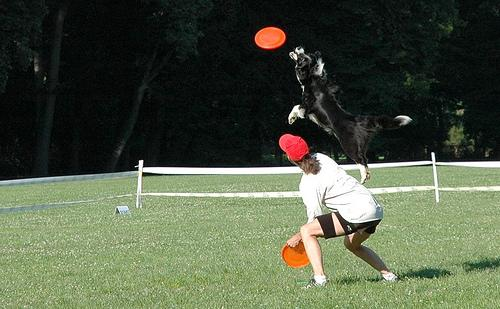What is the primary activity captured in the image? A person playing frisbee with a black and white dog in an outdoor field with lush green grass, white fence, and trees in the background. How would you assess the quality of the image in terms of color, contrast, and composition? The image has vibrant colors with good contrasts, maintaining focus on the main subjects, and a balanced composition to capture the entire scene. Which personal accessory does the woman in the picture wear? The woman is wearing a red hat. How many objects or living beings are involved in the primary action of the image? There are three: the woman, the dog, and the frisbee. Identify one significant object in the background of the photo. A large white fence in the middle of the field with green grass all around. Can you identify the color and type of frisbee in the picture? The frisbee is orange-colored. What is the main emotion or sentiment that this picture evokes? Excitement and playfulness, as a woman and her dog enjoy a lively game of frisbee in a sunny outdoor setting. Explain the positioning of the woman and the dog in the frame. The woman is wearing a red cap, white t-shirt, and is preparing to throw the frisbee, while the dog is jumping up to catch it with its tail and front paw visible. Describe the overall atmosphere and mood of the image. A sunny day with long shadows in a grassy field where a woman and a dog are enjoying playing frisbee together. Perform an analysis of the interaction between the dog and the frisbee. The dog is attempting an impressive vertical leap, trying to catch the orange frisbee that the woman is preparing to throw. 